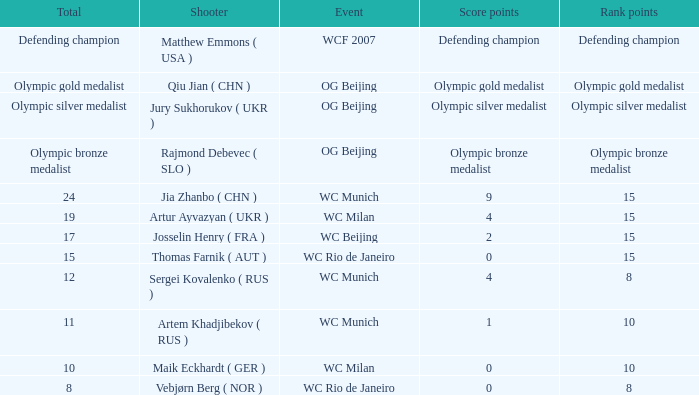With a total of 11, what is the score points? 1.0. Can you give me this table as a dict? {'header': ['Total', 'Shooter', 'Event', 'Score points', 'Rank points'], 'rows': [['Defending champion', 'Matthew Emmons ( USA )', 'WCF 2007', 'Defending champion', 'Defending champion'], ['Olympic gold medalist', 'Qiu Jian ( CHN )', 'OG Beijing', 'Olympic gold medalist', 'Olympic gold medalist'], ['Olympic silver medalist', 'Jury Sukhorukov ( UKR )', 'OG Beijing', 'Olympic silver medalist', 'Olympic silver medalist'], ['Olympic bronze medalist', 'Rajmond Debevec ( SLO )', 'OG Beijing', 'Olympic bronze medalist', 'Olympic bronze medalist'], ['24', 'Jia Zhanbo ( CHN )', 'WC Munich', '9', '15'], ['19', 'Artur Ayvazyan ( UKR )', 'WC Milan', '4', '15'], ['17', 'Josselin Henry ( FRA )', 'WC Beijing', '2', '15'], ['15', 'Thomas Farnik ( AUT )', 'WC Rio de Janeiro', '0', '15'], ['12', 'Sergei Kovalenko ( RUS )', 'WC Munich', '4', '8'], ['11', 'Artem Khadjibekov ( RUS )', 'WC Munich', '1', '10'], ['10', 'Maik Eckhardt ( GER )', 'WC Milan', '0', '10'], ['8', 'Vebjørn Berg ( NOR )', 'WC Rio de Janeiro', '0', '8']]} 